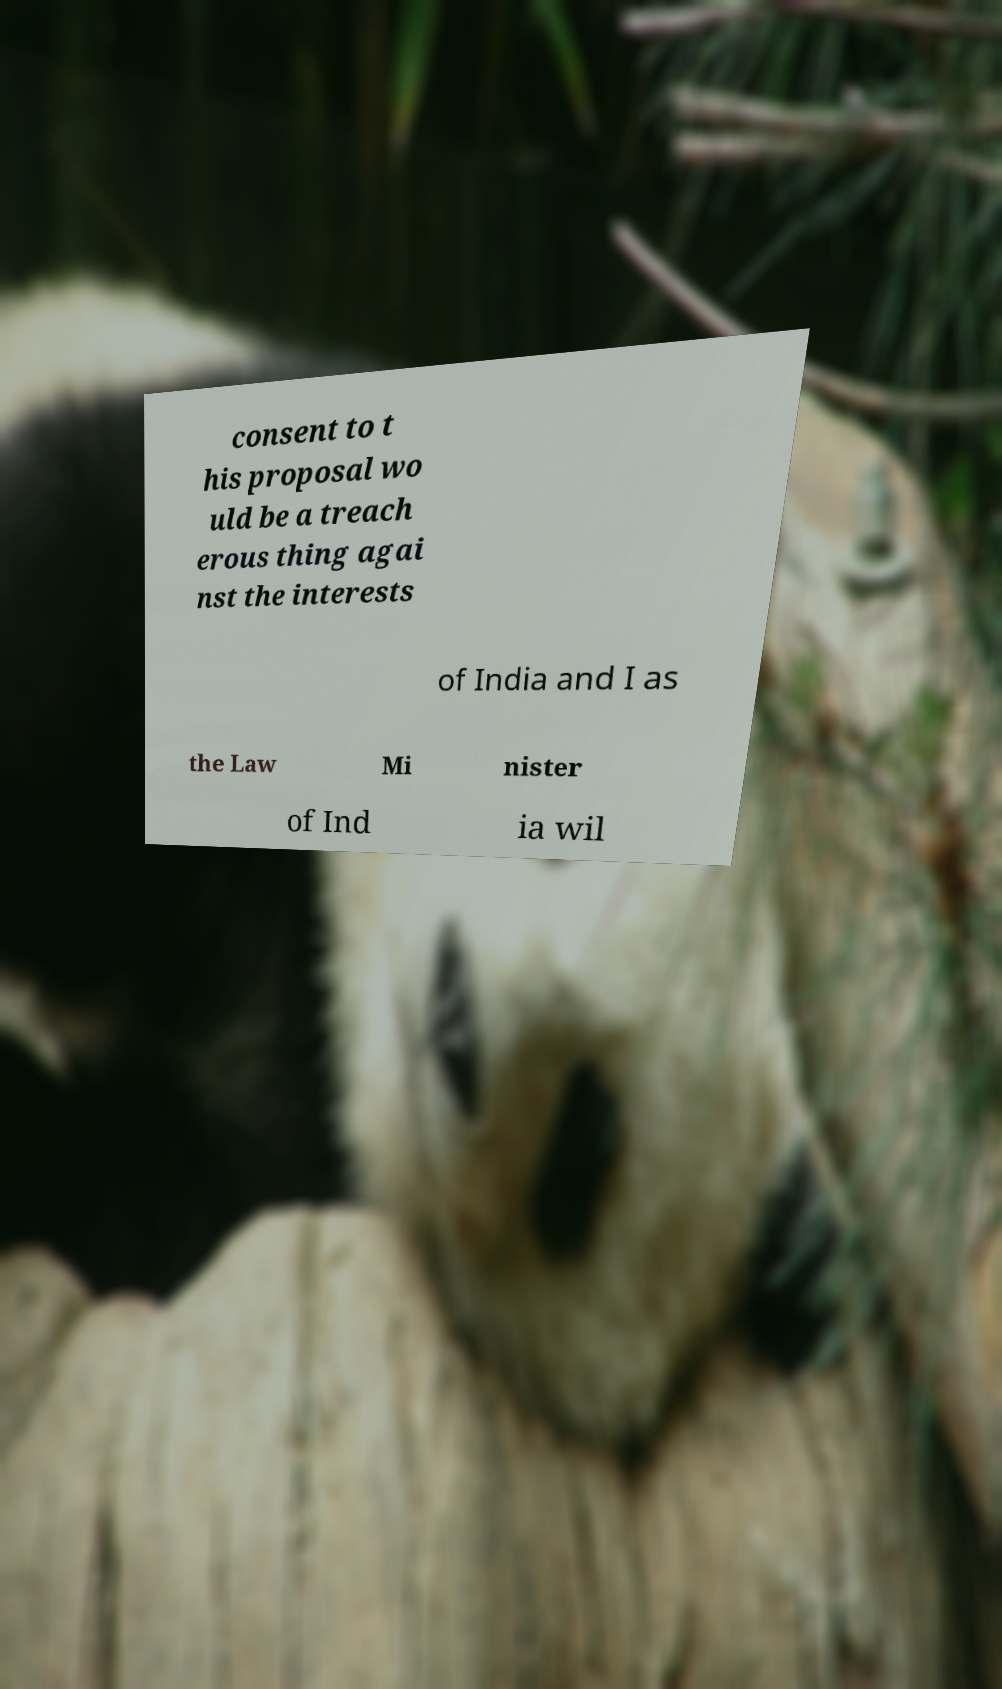For documentation purposes, I need the text within this image transcribed. Could you provide that? consent to t his proposal wo uld be a treach erous thing agai nst the interests of India and I as the Law Mi nister of Ind ia wil 